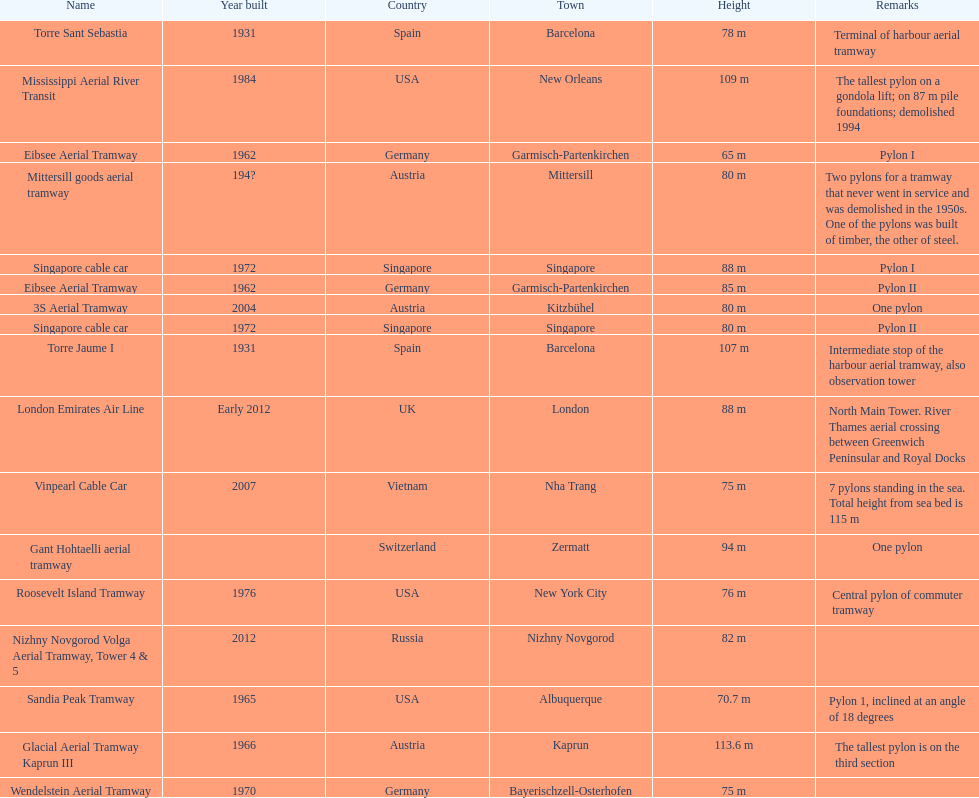How many metres is the tallest pylon? 113.6 m. 